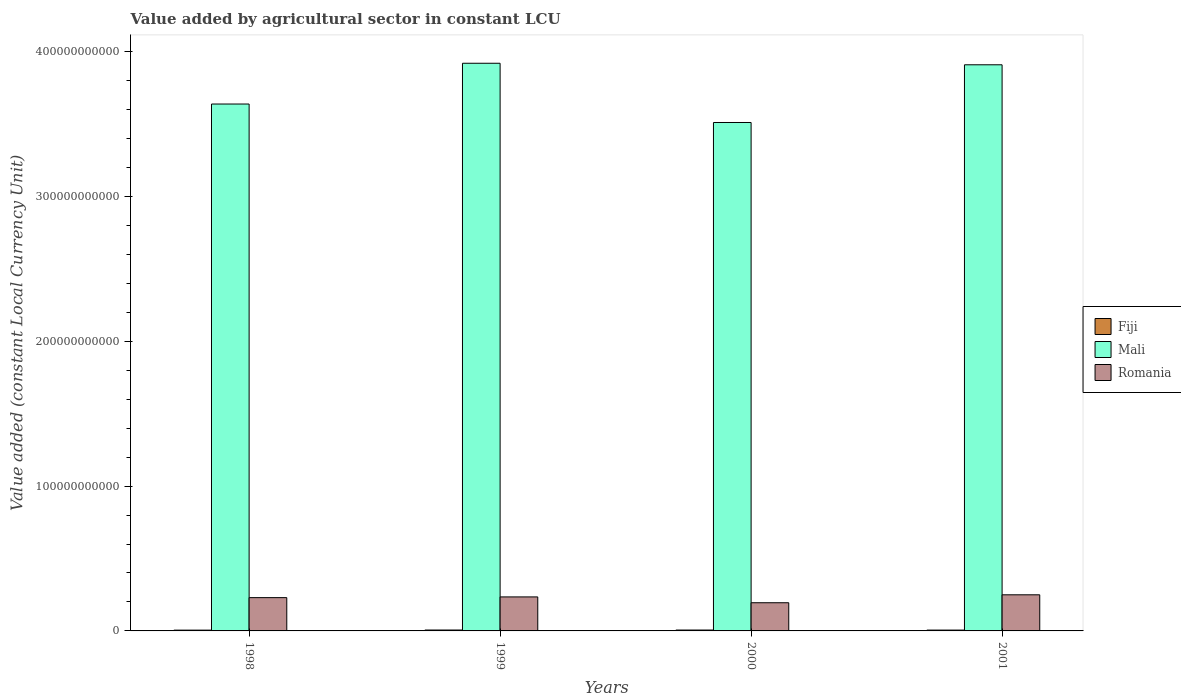Are the number of bars per tick equal to the number of legend labels?
Offer a terse response. Yes. Are the number of bars on each tick of the X-axis equal?
Your answer should be compact. Yes. How many bars are there on the 1st tick from the right?
Offer a terse response. 3. What is the label of the 1st group of bars from the left?
Your answer should be very brief. 1998. In how many cases, is the number of bars for a given year not equal to the number of legend labels?
Provide a short and direct response. 0. What is the value added by agricultural sector in Fiji in 2000?
Your response must be concise. 6.07e+08. Across all years, what is the maximum value added by agricultural sector in Fiji?
Give a very brief answer. 6.15e+08. Across all years, what is the minimum value added by agricultural sector in Romania?
Provide a succinct answer. 1.95e+1. In which year was the value added by agricultural sector in Mali maximum?
Provide a succinct answer. 1999. What is the total value added by agricultural sector in Fiji in the graph?
Make the answer very short. 2.34e+09. What is the difference between the value added by agricultural sector in Fiji in 1998 and that in 1999?
Make the answer very short. -7.37e+07. What is the difference between the value added by agricultural sector in Fiji in 2000 and the value added by agricultural sector in Mali in 1998?
Give a very brief answer. -3.63e+11. What is the average value added by agricultural sector in Romania per year?
Give a very brief answer. 2.27e+1. In the year 1999, what is the difference between the value added by agricultural sector in Fiji and value added by agricultural sector in Mali?
Provide a succinct answer. -3.91e+11. In how many years, is the value added by agricultural sector in Mali greater than 380000000000 LCU?
Your answer should be very brief. 2. What is the ratio of the value added by agricultural sector in Fiji in 1998 to that in 2000?
Ensure brevity in your answer.  0.89. Is the value added by agricultural sector in Romania in 1999 less than that in 2001?
Your response must be concise. Yes. What is the difference between the highest and the second highest value added by agricultural sector in Mali?
Your response must be concise. 1.06e+09. What is the difference between the highest and the lowest value added by agricultural sector in Mali?
Ensure brevity in your answer.  4.09e+1. Is the sum of the value added by agricultural sector in Mali in 1998 and 2001 greater than the maximum value added by agricultural sector in Romania across all years?
Your answer should be very brief. Yes. What does the 2nd bar from the left in 2000 represents?
Make the answer very short. Mali. What does the 2nd bar from the right in 1999 represents?
Offer a very short reply. Mali. Are all the bars in the graph horizontal?
Give a very brief answer. No. What is the difference between two consecutive major ticks on the Y-axis?
Provide a succinct answer. 1.00e+11. What is the title of the graph?
Offer a terse response. Value added by agricultural sector in constant LCU. Does "South Asia" appear as one of the legend labels in the graph?
Your answer should be very brief. No. What is the label or title of the X-axis?
Your answer should be compact. Years. What is the label or title of the Y-axis?
Your answer should be very brief. Value added (constant Local Currency Unit). What is the Value added (constant Local Currency Unit) of Fiji in 1998?
Give a very brief answer. 5.41e+08. What is the Value added (constant Local Currency Unit) of Mali in 1998?
Make the answer very short. 3.64e+11. What is the Value added (constant Local Currency Unit) in Romania in 1998?
Keep it short and to the point. 2.30e+1. What is the Value added (constant Local Currency Unit) in Fiji in 1999?
Your response must be concise. 6.15e+08. What is the Value added (constant Local Currency Unit) of Mali in 1999?
Ensure brevity in your answer.  3.92e+11. What is the Value added (constant Local Currency Unit) of Romania in 1999?
Give a very brief answer. 2.35e+1. What is the Value added (constant Local Currency Unit) in Fiji in 2000?
Provide a short and direct response. 6.07e+08. What is the Value added (constant Local Currency Unit) in Mali in 2000?
Your answer should be compact. 3.51e+11. What is the Value added (constant Local Currency Unit) in Romania in 2000?
Provide a succinct answer. 1.95e+1. What is the Value added (constant Local Currency Unit) of Fiji in 2001?
Provide a short and direct response. 5.73e+08. What is the Value added (constant Local Currency Unit) in Mali in 2001?
Give a very brief answer. 3.91e+11. What is the Value added (constant Local Currency Unit) of Romania in 2001?
Make the answer very short. 2.49e+1. Across all years, what is the maximum Value added (constant Local Currency Unit) of Fiji?
Provide a short and direct response. 6.15e+08. Across all years, what is the maximum Value added (constant Local Currency Unit) in Mali?
Provide a succinct answer. 3.92e+11. Across all years, what is the maximum Value added (constant Local Currency Unit) in Romania?
Give a very brief answer. 2.49e+1. Across all years, what is the minimum Value added (constant Local Currency Unit) in Fiji?
Provide a succinct answer. 5.41e+08. Across all years, what is the minimum Value added (constant Local Currency Unit) in Mali?
Offer a terse response. 3.51e+11. Across all years, what is the minimum Value added (constant Local Currency Unit) of Romania?
Provide a short and direct response. 1.95e+1. What is the total Value added (constant Local Currency Unit) of Fiji in the graph?
Your answer should be very brief. 2.34e+09. What is the total Value added (constant Local Currency Unit) in Mali in the graph?
Offer a terse response. 1.50e+12. What is the total Value added (constant Local Currency Unit) of Romania in the graph?
Keep it short and to the point. 9.09e+1. What is the difference between the Value added (constant Local Currency Unit) in Fiji in 1998 and that in 1999?
Your response must be concise. -7.37e+07. What is the difference between the Value added (constant Local Currency Unit) in Mali in 1998 and that in 1999?
Offer a terse response. -2.82e+1. What is the difference between the Value added (constant Local Currency Unit) of Romania in 1998 and that in 1999?
Your response must be concise. -4.91e+08. What is the difference between the Value added (constant Local Currency Unit) of Fiji in 1998 and that in 2000?
Ensure brevity in your answer.  -6.60e+07. What is the difference between the Value added (constant Local Currency Unit) of Mali in 1998 and that in 2000?
Give a very brief answer. 1.28e+1. What is the difference between the Value added (constant Local Currency Unit) in Romania in 1998 and that in 2000?
Your answer should be compact. 3.53e+09. What is the difference between the Value added (constant Local Currency Unit) of Fiji in 1998 and that in 2001?
Offer a terse response. -3.14e+07. What is the difference between the Value added (constant Local Currency Unit) in Mali in 1998 and that in 2001?
Provide a succinct answer. -2.71e+1. What is the difference between the Value added (constant Local Currency Unit) of Romania in 1998 and that in 2001?
Provide a short and direct response. -1.95e+09. What is the difference between the Value added (constant Local Currency Unit) in Fiji in 1999 and that in 2000?
Your response must be concise. 7.78e+06. What is the difference between the Value added (constant Local Currency Unit) of Mali in 1999 and that in 2000?
Ensure brevity in your answer.  4.09e+1. What is the difference between the Value added (constant Local Currency Unit) of Romania in 1999 and that in 2000?
Your answer should be compact. 4.03e+09. What is the difference between the Value added (constant Local Currency Unit) in Fiji in 1999 and that in 2001?
Your response must be concise. 4.24e+07. What is the difference between the Value added (constant Local Currency Unit) in Mali in 1999 and that in 2001?
Give a very brief answer. 1.06e+09. What is the difference between the Value added (constant Local Currency Unit) in Romania in 1999 and that in 2001?
Keep it short and to the point. -1.46e+09. What is the difference between the Value added (constant Local Currency Unit) of Fiji in 2000 and that in 2001?
Your answer should be very brief. 3.46e+07. What is the difference between the Value added (constant Local Currency Unit) of Mali in 2000 and that in 2001?
Provide a short and direct response. -3.98e+1. What is the difference between the Value added (constant Local Currency Unit) of Romania in 2000 and that in 2001?
Your answer should be compact. -5.48e+09. What is the difference between the Value added (constant Local Currency Unit) in Fiji in 1998 and the Value added (constant Local Currency Unit) in Mali in 1999?
Offer a very short reply. -3.91e+11. What is the difference between the Value added (constant Local Currency Unit) of Fiji in 1998 and the Value added (constant Local Currency Unit) of Romania in 1999?
Provide a succinct answer. -2.29e+1. What is the difference between the Value added (constant Local Currency Unit) of Mali in 1998 and the Value added (constant Local Currency Unit) of Romania in 1999?
Your response must be concise. 3.40e+11. What is the difference between the Value added (constant Local Currency Unit) of Fiji in 1998 and the Value added (constant Local Currency Unit) of Mali in 2000?
Provide a succinct answer. -3.51e+11. What is the difference between the Value added (constant Local Currency Unit) in Fiji in 1998 and the Value added (constant Local Currency Unit) in Romania in 2000?
Offer a terse response. -1.89e+1. What is the difference between the Value added (constant Local Currency Unit) of Mali in 1998 and the Value added (constant Local Currency Unit) of Romania in 2000?
Your answer should be compact. 3.44e+11. What is the difference between the Value added (constant Local Currency Unit) in Fiji in 1998 and the Value added (constant Local Currency Unit) in Mali in 2001?
Offer a terse response. -3.90e+11. What is the difference between the Value added (constant Local Currency Unit) of Fiji in 1998 and the Value added (constant Local Currency Unit) of Romania in 2001?
Ensure brevity in your answer.  -2.44e+1. What is the difference between the Value added (constant Local Currency Unit) in Mali in 1998 and the Value added (constant Local Currency Unit) in Romania in 2001?
Offer a terse response. 3.39e+11. What is the difference between the Value added (constant Local Currency Unit) of Fiji in 1999 and the Value added (constant Local Currency Unit) of Mali in 2000?
Provide a succinct answer. -3.50e+11. What is the difference between the Value added (constant Local Currency Unit) in Fiji in 1999 and the Value added (constant Local Currency Unit) in Romania in 2000?
Keep it short and to the point. -1.88e+1. What is the difference between the Value added (constant Local Currency Unit) of Mali in 1999 and the Value added (constant Local Currency Unit) of Romania in 2000?
Ensure brevity in your answer.  3.73e+11. What is the difference between the Value added (constant Local Currency Unit) in Fiji in 1999 and the Value added (constant Local Currency Unit) in Mali in 2001?
Your answer should be very brief. -3.90e+11. What is the difference between the Value added (constant Local Currency Unit) of Fiji in 1999 and the Value added (constant Local Currency Unit) of Romania in 2001?
Your answer should be compact. -2.43e+1. What is the difference between the Value added (constant Local Currency Unit) of Mali in 1999 and the Value added (constant Local Currency Unit) of Romania in 2001?
Provide a short and direct response. 3.67e+11. What is the difference between the Value added (constant Local Currency Unit) of Fiji in 2000 and the Value added (constant Local Currency Unit) of Mali in 2001?
Your answer should be compact. -3.90e+11. What is the difference between the Value added (constant Local Currency Unit) of Fiji in 2000 and the Value added (constant Local Currency Unit) of Romania in 2001?
Offer a very short reply. -2.43e+1. What is the difference between the Value added (constant Local Currency Unit) in Mali in 2000 and the Value added (constant Local Currency Unit) in Romania in 2001?
Keep it short and to the point. 3.26e+11. What is the average Value added (constant Local Currency Unit) in Fiji per year?
Make the answer very short. 5.84e+08. What is the average Value added (constant Local Currency Unit) in Mali per year?
Ensure brevity in your answer.  3.74e+11. What is the average Value added (constant Local Currency Unit) in Romania per year?
Ensure brevity in your answer.  2.27e+1. In the year 1998, what is the difference between the Value added (constant Local Currency Unit) in Fiji and Value added (constant Local Currency Unit) in Mali?
Your answer should be very brief. -3.63e+11. In the year 1998, what is the difference between the Value added (constant Local Currency Unit) of Fiji and Value added (constant Local Currency Unit) of Romania?
Provide a succinct answer. -2.24e+1. In the year 1998, what is the difference between the Value added (constant Local Currency Unit) of Mali and Value added (constant Local Currency Unit) of Romania?
Give a very brief answer. 3.41e+11. In the year 1999, what is the difference between the Value added (constant Local Currency Unit) of Fiji and Value added (constant Local Currency Unit) of Mali?
Offer a terse response. -3.91e+11. In the year 1999, what is the difference between the Value added (constant Local Currency Unit) in Fiji and Value added (constant Local Currency Unit) in Romania?
Your answer should be very brief. -2.29e+1. In the year 1999, what is the difference between the Value added (constant Local Currency Unit) of Mali and Value added (constant Local Currency Unit) of Romania?
Your response must be concise. 3.69e+11. In the year 2000, what is the difference between the Value added (constant Local Currency Unit) of Fiji and Value added (constant Local Currency Unit) of Mali?
Your answer should be very brief. -3.51e+11. In the year 2000, what is the difference between the Value added (constant Local Currency Unit) in Fiji and Value added (constant Local Currency Unit) in Romania?
Keep it short and to the point. -1.88e+1. In the year 2000, what is the difference between the Value added (constant Local Currency Unit) of Mali and Value added (constant Local Currency Unit) of Romania?
Your answer should be very brief. 3.32e+11. In the year 2001, what is the difference between the Value added (constant Local Currency Unit) of Fiji and Value added (constant Local Currency Unit) of Mali?
Give a very brief answer. -3.90e+11. In the year 2001, what is the difference between the Value added (constant Local Currency Unit) in Fiji and Value added (constant Local Currency Unit) in Romania?
Your answer should be compact. -2.44e+1. In the year 2001, what is the difference between the Value added (constant Local Currency Unit) in Mali and Value added (constant Local Currency Unit) in Romania?
Your response must be concise. 3.66e+11. What is the ratio of the Value added (constant Local Currency Unit) of Fiji in 1998 to that in 1999?
Make the answer very short. 0.88. What is the ratio of the Value added (constant Local Currency Unit) of Mali in 1998 to that in 1999?
Keep it short and to the point. 0.93. What is the ratio of the Value added (constant Local Currency Unit) of Romania in 1998 to that in 1999?
Offer a terse response. 0.98. What is the ratio of the Value added (constant Local Currency Unit) of Fiji in 1998 to that in 2000?
Keep it short and to the point. 0.89. What is the ratio of the Value added (constant Local Currency Unit) in Mali in 1998 to that in 2000?
Provide a succinct answer. 1.04. What is the ratio of the Value added (constant Local Currency Unit) in Romania in 1998 to that in 2000?
Give a very brief answer. 1.18. What is the ratio of the Value added (constant Local Currency Unit) in Fiji in 1998 to that in 2001?
Your response must be concise. 0.95. What is the ratio of the Value added (constant Local Currency Unit) of Mali in 1998 to that in 2001?
Keep it short and to the point. 0.93. What is the ratio of the Value added (constant Local Currency Unit) of Romania in 1998 to that in 2001?
Offer a very short reply. 0.92. What is the ratio of the Value added (constant Local Currency Unit) of Fiji in 1999 to that in 2000?
Your response must be concise. 1.01. What is the ratio of the Value added (constant Local Currency Unit) in Mali in 1999 to that in 2000?
Keep it short and to the point. 1.12. What is the ratio of the Value added (constant Local Currency Unit) of Romania in 1999 to that in 2000?
Offer a terse response. 1.21. What is the ratio of the Value added (constant Local Currency Unit) in Fiji in 1999 to that in 2001?
Give a very brief answer. 1.07. What is the ratio of the Value added (constant Local Currency Unit) of Mali in 1999 to that in 2001?
Your answer should be compact. 1. What is the ratio of the Value added (constant Local Currency Unit) in Romania in 1999 to that in 2001?
Your answer should be compact. 0.94. What is the ratio of the Value added (constant Local Currency Unit) in Fiji in 2000 to that in 2001?
Give a very brief answer. 1.06. What is the ratio of the Value added (constant Local Currency Unit) in Mali in 2000 to that in 2001?
Provide a succinct answer. 0.9. What is the ratio of the Value added (constant Local Currency Unit) in Romania in 2000 to that in 2001?
Provide a succinct answer. 0.78. What is the difference between the highest and the second highest Value added (constant Local Currency Unit) of Fiji?
Give a very brief answer. 7.78e+06. What is the difference between the highest and the second highest Value added (constant Local Currency Unit) in Mali?
Provide a short and direct response. 1.06e+09. What is the difference between the highest and the second highest Value added (constant Local Currency Unit) of Romania?
Your response must be concise. 1.46e+09. What is the difference between the highest and the lowest Value added (constant Local Currency Unit) of Fiji?
Provide a succinct answer. 7.37e+07. What is the difference between the highest and the lowest Value added (constant Local Currency Unit) in Mali?
Keep it short and to the point. 4.09e+1. What is the difference between the highest and the lowest Value added (constant Local Currency Unit) of Romania?
Offer a very short reply. 5.48e+09. 